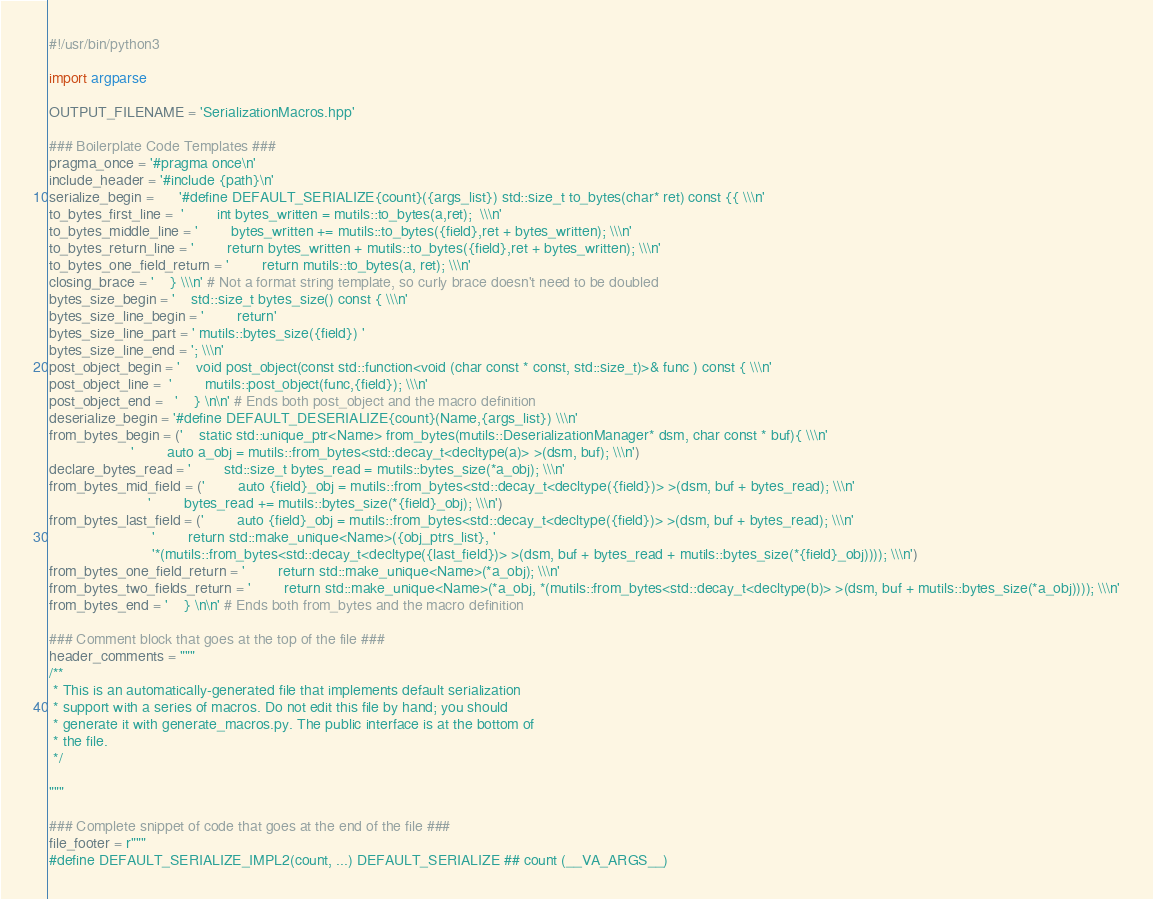Convert code to text. <code><loc_0><loc_0><loc_500><loc_500><_Python_>#!/usr/bin/python3

import argparse

OUTPUT_FILENAME = 'SerializationMacros.hpp'

### Boilerplate Code Templates ###
pragma_once = '#pragma once\n'
include_header = '#include {path}\n'
serialize_begin =      '#define DEFAULT_SERIALIZE{count}({args_list}) std::size_t to_bytes(char* ret) const {{ \\\n'
to_bytes_first_line =  '        int bytes_written = mutils::to_bytes(a,ret);  \\\n'
to_bytes_middle_line = '        bytes_written += mutils::to_bytes({field},ret + bytes_written); \\\n'
to_bytes_return_line = '        return bytes_written + mutils::to_bytes({field},ret + bytes_written); \\\n'
to_bytes_one_field_return = '        return mutils::to_bytes(a, ret); \\\n'
closing_brace = '    } \\\n' # Not a format string template, so curly brace doesn't need to be doubled
bytes_size_begin = '    std::size_t bytes_size() const { \\\n'
bytes_size_line_begin = '        return'
bytes_size_line_part = ' mutils::bytes_size({field}) '
bytes_size_line_end = '; \\\n'
post_object_begin = '    void post_object(const std::function<void (char const * const, std::size_t)>& func ) const { \\\n'
post_object_line =  '        mutils::post_object(func,{field}); \\\n'
post_object_end =   '    } \n\n' # Ends both post_object and the macro definition
deserialize_begin = '#define DEFAULT_DESERIALIZE{count}(Name,{args_list}) \\\n'
from_bytes_begin = ('    static std::unique_ptr<Name> from_bytes(mutils::DeserializationManager* dsm, char const * buf){ \\\n'
                    '        auto a_obj = mutils::from_bytes<std::decay_t<decltype(a)> >(dsm, buf); \\\n')
declare_bytes_read = '        std::size_t bytes_read = mutils::bytes_size(*a_obj); \\\n'
from_bytes_mid_field = ('        auto {field}_obj = mutils::from_bytes<std::decay_t<decltype({field})> >(dsm, buf + bytes_read); \\\n'
                        '        bytes_read += mutils::bytes_size(*{field}_obj); \\\n')
from_bytes_last_field = ('        auto {field}_obj = mutils::from_bytes<std::decay_t<decltype({field})> >(dsm, buf + bytes_read); \\\n'
                         '        return std::make_unique<Name>({obj_ptrs_list}, '
                         '*(mutils::from_bytes<std::decay_t<decltype({last_field})> >(dsm, buf + bytes_read + mutils::bytes_size(*{field}_obj)))); \\\n')
from_bytes_one_field_return = '        return std::make_unique<Name>(*a_obj); \\\n'
from_bytes_two_fields_return = '        return std::make_unique<Name>(*a_obj, *(mutils::from_bytes<std::decay_t<decltype(b)> >(dsm, buf + mutils::bytes_size(*a_obj)))); \\\n'
from_bytes_end = '    } \n\n' # Ends both from_bytes and the macro definition

### Comment block that goes at the top of the file ###
header_comments = """
/**
 * This is an automatically-generated file that implements default serialization
 * support with a series of macros. Do not edit this file by hand; you should
 * generate it with generate_macros.py. The public interface is at the bottom of
 * the file.
 */

"""

### Complete snippet of code that goes at the end of the file ###
file_footer = r"""
#define DEFAULT_SERIALIZE_IMPL2(count, ...) DEFAULT_SERIALIZE ## count (__VA_ARGS__)</code> 